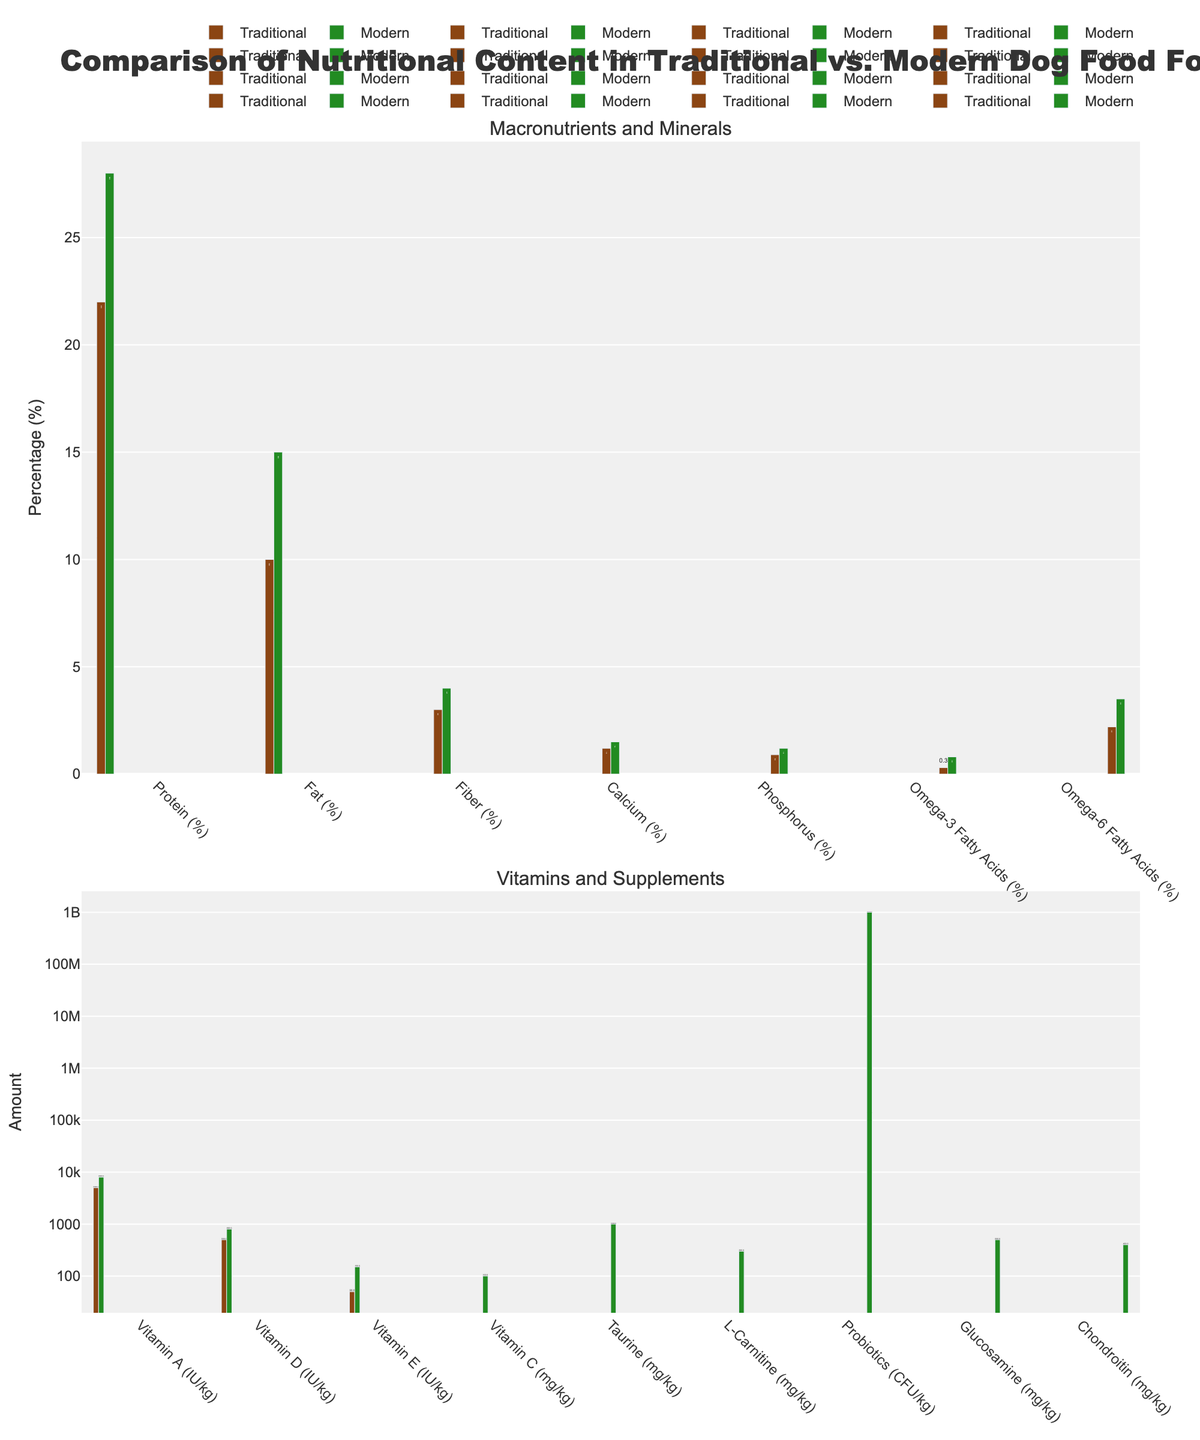What's the difference in protein content between traditional and modern formulations? The bar for protein content in traditional formulation is labeled 22%, while the bar for modern formulation is labeled 28%. Subtract the traditional value from the modern value: 28% - 22% = 6%.
Answer: 6% Which formulation has a higher fat content, and by how much? The traditional formulation's bar for fat content shows 10%, and the modern formulation's bar shows 15%. Modern formulation has higher fat content. Subtract traditional value from modern value: 15% - 10% = 5%.
Answer: Modern, 5% What is the combined percentage of Fiber and Calcium in modern formulation? Look at the bars for Fiber and Calcium in modern formulation which show 4% and 1.5% respectively. Add these values together: 4% + 1.5% = 5.5%.
Answer: 5.5% Comparing traditional and modern formulations, which nutrient shows the greatest percentage increase? Calculate the percentage increase for each nutrient from the traditional to modern formulation and find the largest: 
Protein: (28-22)/22 ≈ 27.3% 
Fat: (15-10)/10 = 50% 
Fiber: (4-3)/3 ≈ 33.3% 
Calcium: (1.5-1.2)/1.2 ≈ 25% 
Phosphorus: (1.2-0.9)/0.9 ≈ 33.3% 
Omega-3: (0.8-0.3)/0.3 ≈ 166.7% 
Omega-6: (3.5-2.2)/2.2 ≈ 59.1% 
The greatest increase is in Omega-3 fatty acids.
Answer: Omega-3 Fatty Acids What visual attribute differentiates the nutrients in the modern formulation from those in the traditional formulation? The bars representing nutrients in the modern formulation are green, while those for the traditional formulation are brown.
Answer: Color of the bars Which formulation contains Vitamin C, and what is its amount? The figure shows a bar for Vitamin C only in the modern formulation, labeled 100 mg/kg. Traditional has none.
Answer: Modern, 100 mg/kg How does the taurine content in modern formulation compare to traditional formulation? The traditional formulation has a bar labeled 0 mg/kg for taurine, while the modern formulation shows a bar with 1000 mg/kg.
Answer: Modern has 1000 mg/kg, traditional has none What is the difference in Vitamin E content between formulations? Traditional formulation shows a Vitamin E content of 50 IU/kg, and modern formulation shows 150 IU/kg. Subtract: 150 - 50 = 100 IU/kg.
Answer: 100 IU/kg Are there any nutritional elements present in modern formulations but absent in traditional? Yes, there are several nutrients such as Vitamin C, Taurine, L-Carnitine, Probiotics, Glucosamine, and Chondroitin present in modern formulations but absent in traditional formulations.
Answer: Yes 